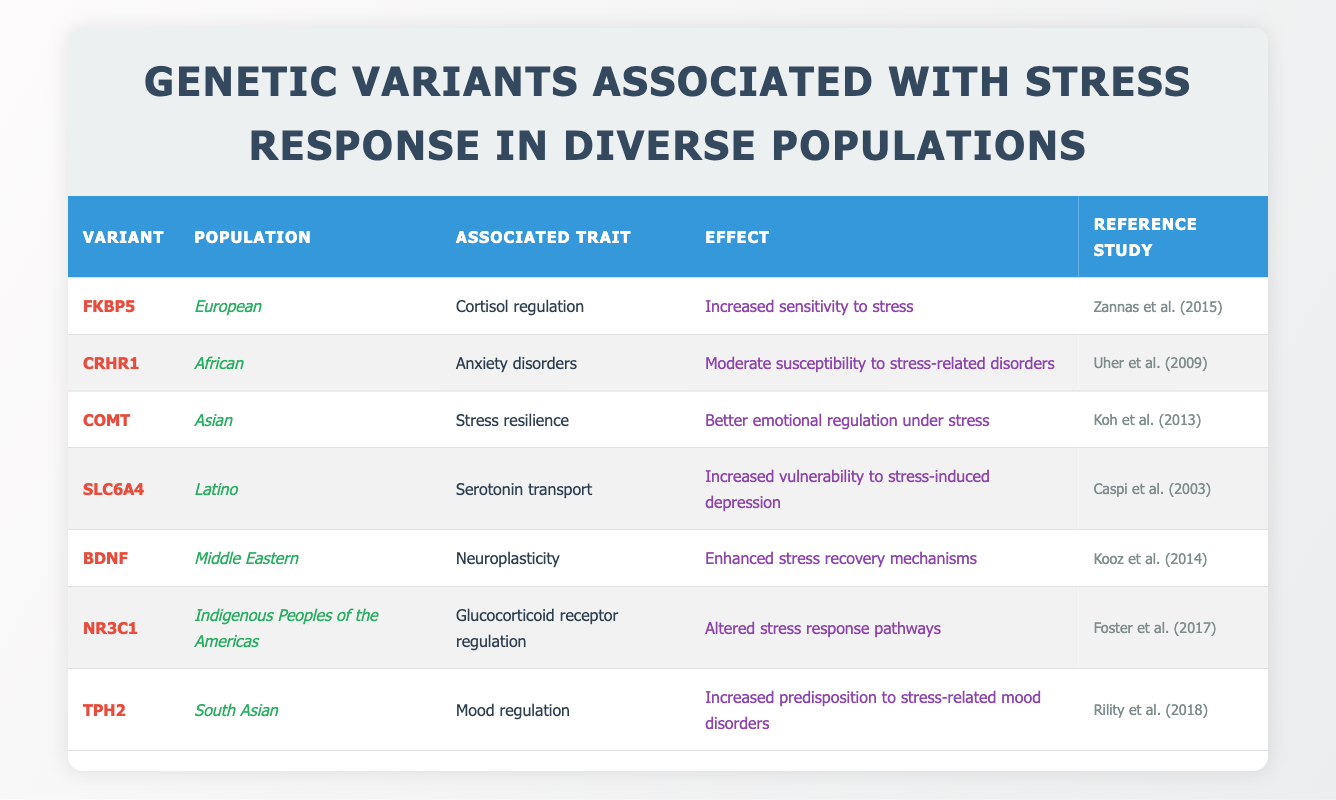What is the associated trait for the FKBP5 variant in the European population? In the table, look for the FKBP5 variant and read across to find the "Associated Trait" column. It states that FKBP5 is associated with "Cortisol regulation."
Answer: Cortisol regulation Which genetic variant in the Latino population is associated with increased vulnerability to stress-induced depression? Scan the table for the Latino population and find the corresponding variant. It shows that SLC6A4 is associated with increased vulnerability to stress-induced depression.
Answer: SLC6A4 Are there any genetic variants listed that are associated with enhanced stress recovery mechanisms? Review the "Effect" column for any mention of enhancing stress recovery. The BDNF variant is linked to enhanced stress recovery mechanisms.
Answer: Yes, BDNF Which populations have variants that indicate a susceptibility to stress-related disorders? Examine the "Effect" column for mentions of susceptibility and check the populations accordingly. The CRHR1 variant (African population) shows moderate susceptibility, and TPH2 variant (South Asian population) indicates increased predisposition to stress-related mood disorders.
Answer: African and South Asian populations How many genetic variants are associated with stress resilience according to the table? Count the entries in the table and focus on the "Effect" column for terms like "resilience." Here, only the COMT variant is indicated as having stress resilience. Therefore, there is one variant.
Answer: 1 Is the NR3C1 variant in Indigenous Peoples of the Americas linked to altered stress response pathways? Check the row for NR3C1 in the table. It confirms that this variant is indeed associated with altered stress response pathways.
Answer: Yes What are the effects associated with the COMT variant, and which study references it? Locate the row for the COMT variant to find its associated effect and reference. The COMT variant is linked to better emotional regulation under stress, referenced by Koh et al. (2013).
Answer: Better emotional regulation; Koh et al. (2013) Among the listed populations, which one is associated with anxiety disorders? Review the table for the "Associated Trait" column looking for anxiety disorders. The CRHR1 variant in the African population is noted for this trait.
Answer: African population If you wanted to assess overall stress-related mood disorder predisposition across the listed countries, which variants would you consider? Identify variants in the table associated with mood disorders. TPH2 (South Asian) indicates predisposition to stress-related mood disorders, while SLC6A4 (Latino) shows increased vulnerability to stress-induced depression.
Answer: TPH2 and SLC6A4 How does the effect of the BDNF variant compare to that of the FKBP5 variant? Examine the effects stated for both variants. BDNF indicates enhanced stress recovery mechanisms, while FKBP5 indicates increased sensitivity to stress, showing that one aids recovery while the other enhances sensitivity.
Answer: BDNF aids recovery; FKBP5 increases sensitivity 